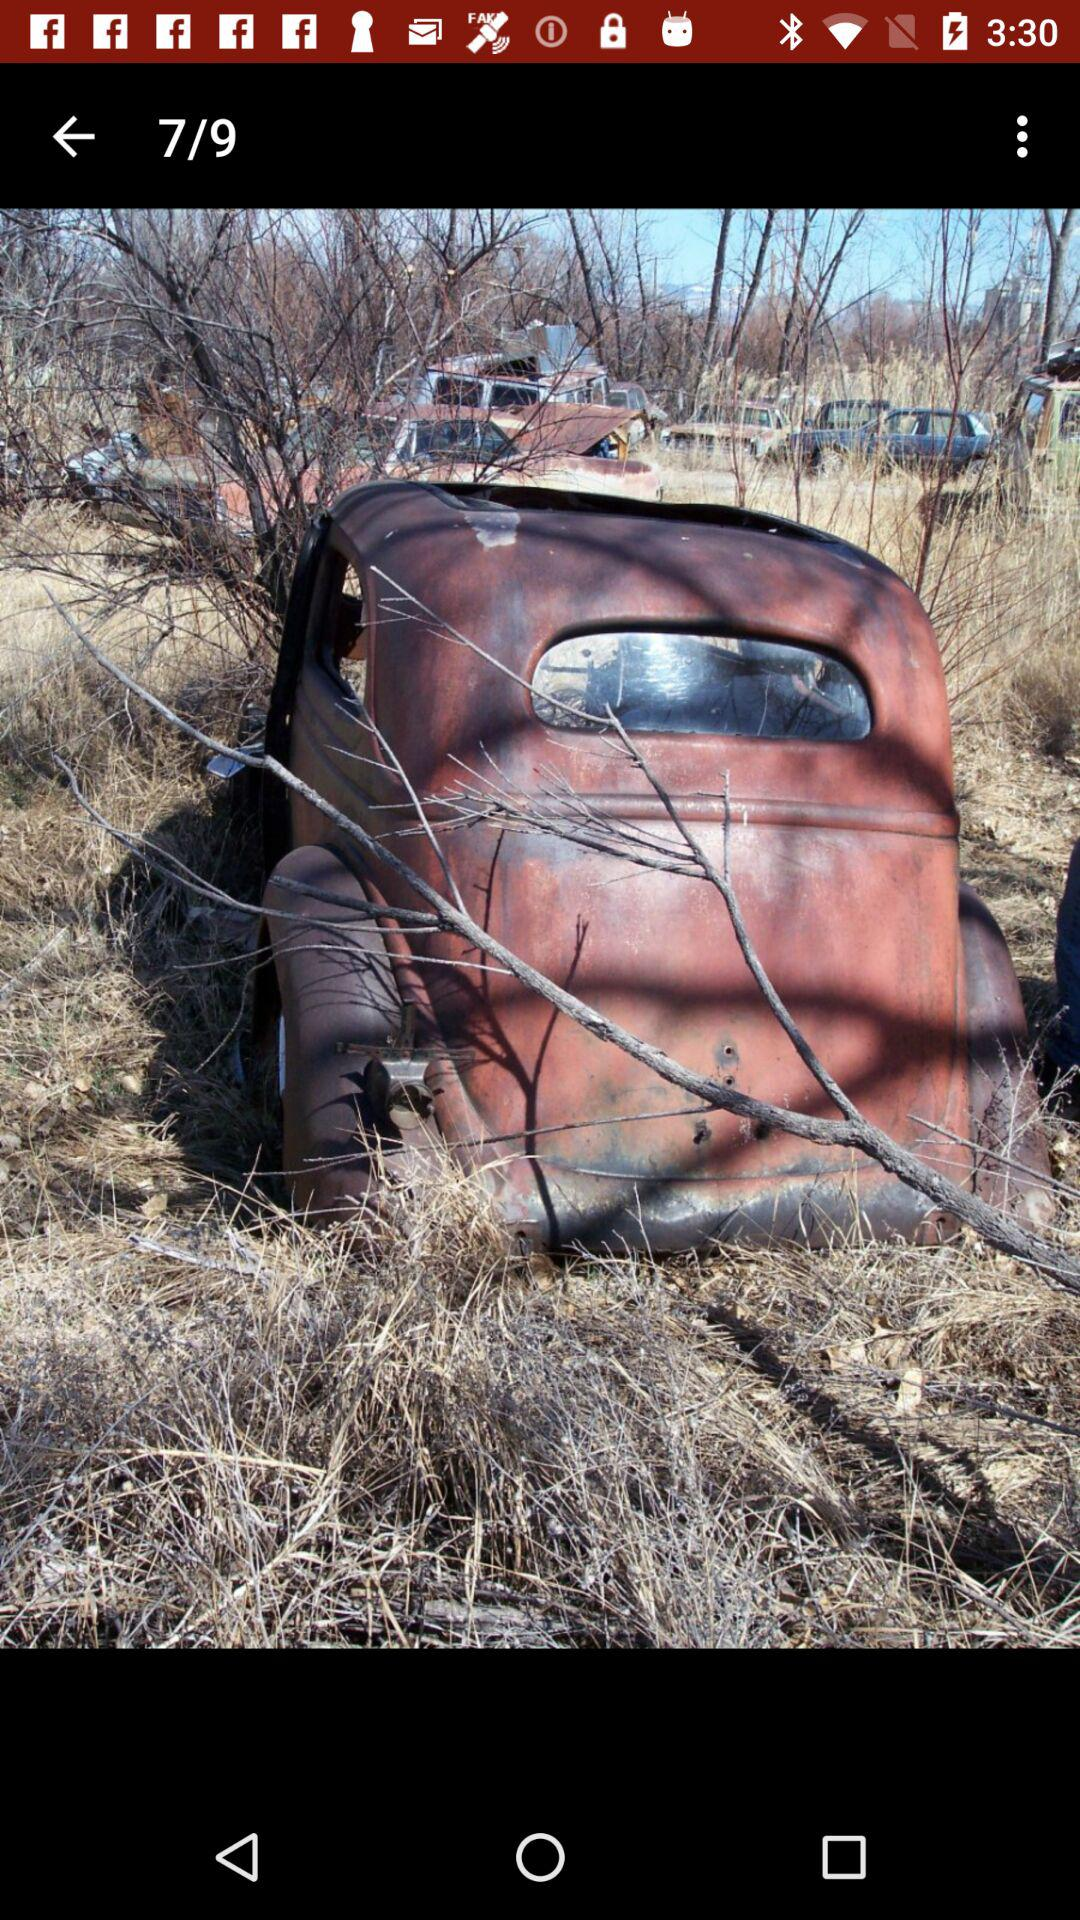Which image am I on? You are on the seventh image. 